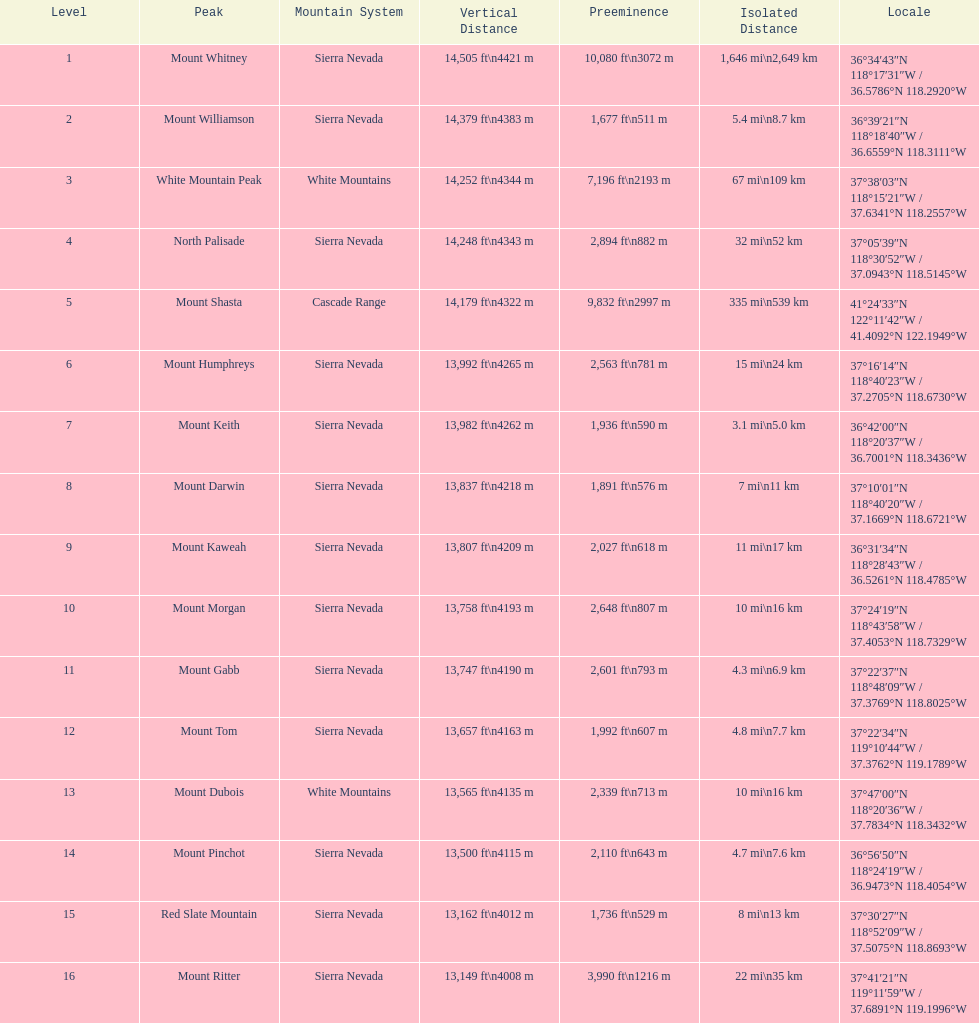What is the loftiest peak in the sierra nevadas? Mount Whitney. 